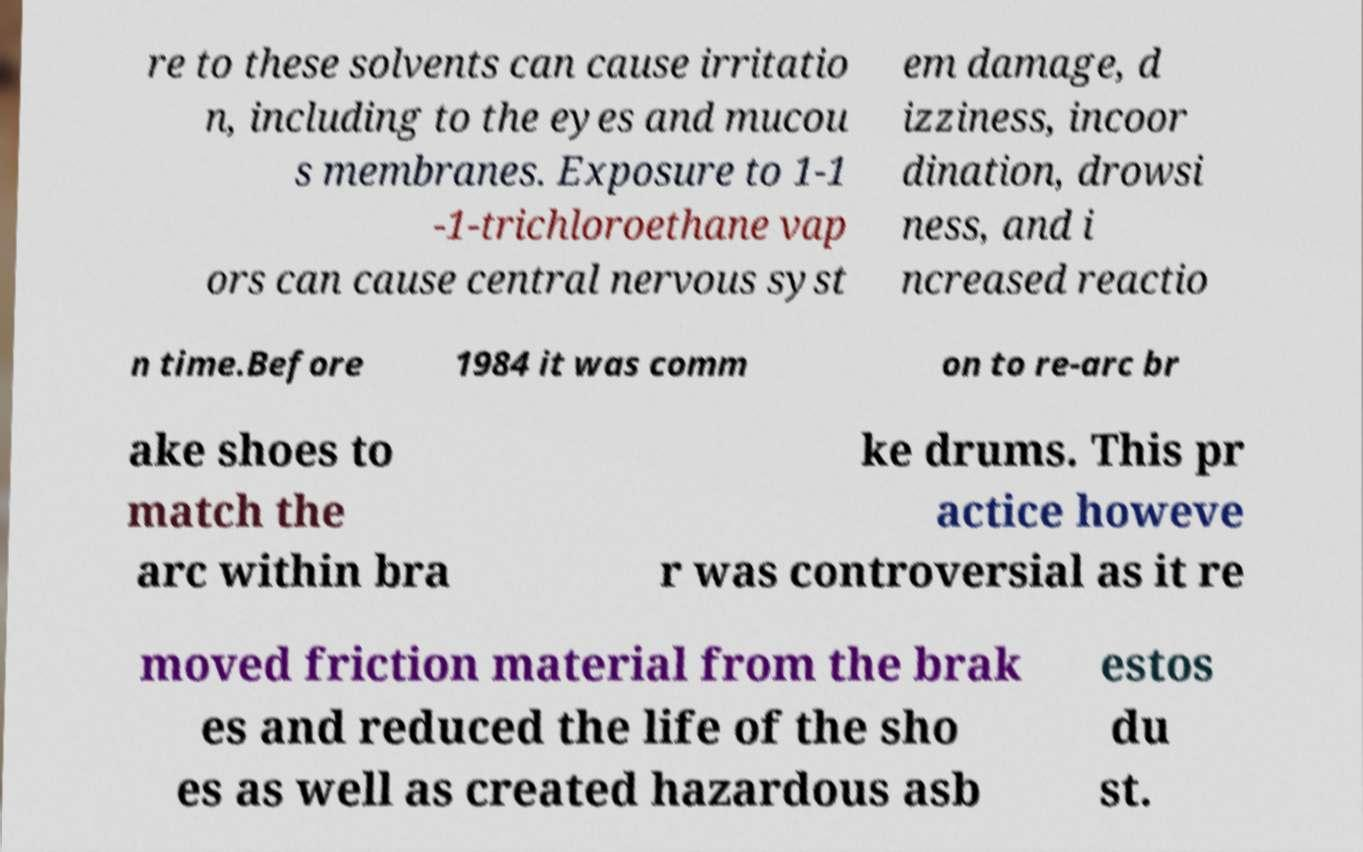I need the written content from this picture converted into text. Can you do that? re to these solvents can cause irritatio n, including to the eyes and mucou s membranes. Exposure to 1-1 -1-trichloroethane vap ors can cause central nervous syst em damage, d izziness, incoor dination, drowsi ness, and i ncreased reactio n time.Before 1984 it was comm on to re-arc br ake shoes to match the arc within bra ke drums. This pr actice howeve r was controversial as it re moved friction material from the brak es and reduced the life of the sho es as well as created hazardous asb estos du st. 